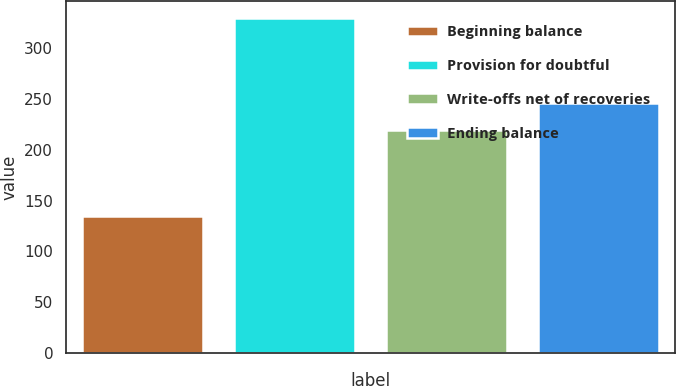<chart> <loc_0><loc_0><loc_500><loc_500><bar_chart><fcel>Beginning balance<fcel>Provision for doubtful<fcel>Write-offs net of recoveries<fcel>Ending balance<nl><fcel>135<fcel>330<fcel>219<fcel>246<nl></chart> 